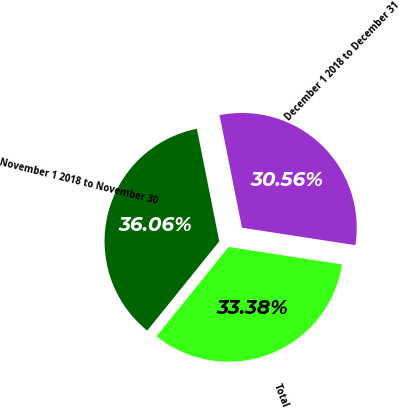<chart> <loc_0><loc_0><loc_500><loc_500><pie_chart><fcel>November 1 2018 to November 30<fcel>December 1 2018 to December 31<fcel>Total<nl><fcel>36.06%<fcel>30.56%<fcel>33.38%<nl></chart> 